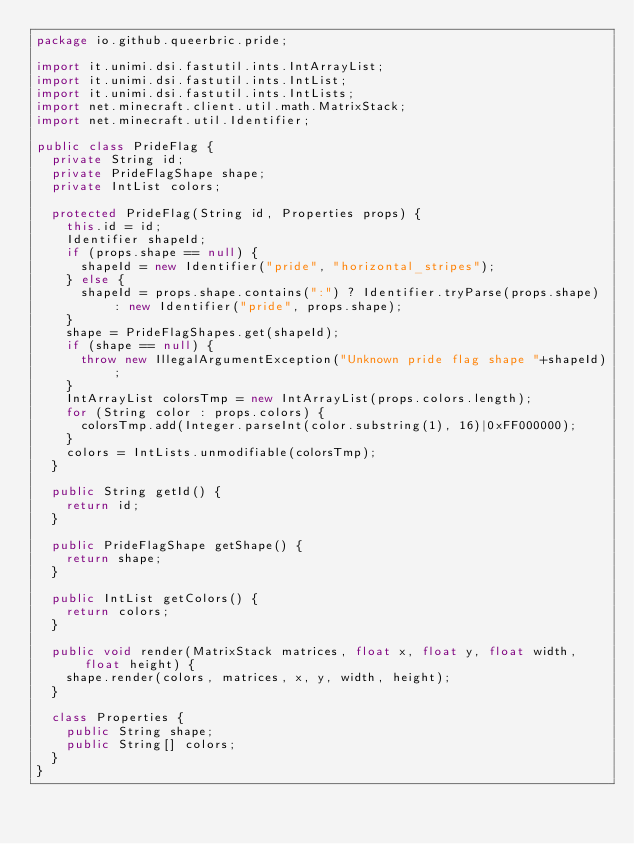Convert code to text. <code><loc_0><loc_0><loc_500><loc_500><_Java_>package io.github.queerbric.pride;

import it.unimi.dsi.fastutil.ints.IntArrayList;
import it.unimi.dsi.fastutil.ints.IntList;
import it.unimi.dsi.fastutil.ints.IntLists;
import net.minecraft.client.util.math.MatrixStack;
import net.minecraft.util.Identifier;

public class PrideFlag {
	private String id;
	private PrideFlagShape shape;
	private IntList colors;

	protected PrideFlag(String id, Properties props) {
		this.id = id;
		Identifier shapeId;
		if (props.shape == null) {
			shapeId = new Identifier("pride", "horizontal_stripes");
		} else {
			shapeId = props.shape.contains(":") ? Identifier.tryParse(props.shape) : new Identifier("pride", props.shape);
		}
		shape = PrideFlagShapes.get(shapeId);
		if (shape == null) {
			throw new IllegalArgumentException("Unknown pride flag shape "+shapeId);
		}
		IntArrayList colorsTmp = new IntArrayList(props.colors.length);
		for (String color : props.colors) {
			colorsTmp.add(Integer.parseInt(color.substring(1), 16)|0xFF000000);
		}
		colors = IntLists.unmodifiable(colorsTmp);
	}

	public String getId() {
		return id;
	}

	public PrideFlagShape getShape() {
		return shape;
	}
	
	public IntList getColors() {
		return colors;
	}
	
	public void render(MatrixStack matrices, float x, float y, float width, float height) {
		shape.render(colors, matrices, x, y, width, height);
	}
	
	class Properties {
		public String shape;
		public String[] colors;
	}
}
</code> 